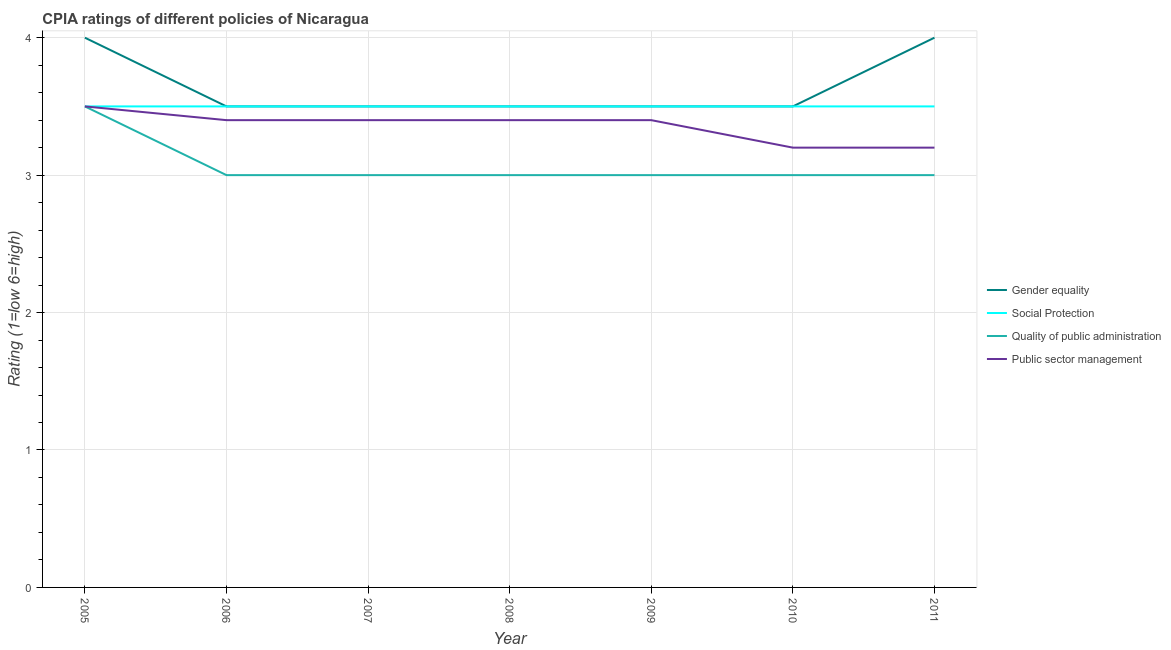Does the line corresponding to cpia rating of quality of public administration intersect with the line corresponding to cpia rating of gender equality?
Ensure brevity in your answer.  No. Is the number of lines equal to the number of legend labels?
Ensure brevity in your answer.  Yes. Across all years, what is the maximum cpia rating of gender equality?
Offer a very short reply. 4. In which year was the cpia rating of social protection minimum?
Keep it short and to the point. 2005. What is the total cpia rating of quality of public administration in the graph?
Your response must be concise. 21.5. What is the difference between the cpia rating of public sector management in 2005 and that in 2008?
Your answer should be very brief. 0.1. What is the average cpia rating of public sector management per year?
Make the answer very short. 3.36. In the year 2006, what is the difference between the cpia rating of public sector management and cpia rating of quality of public administration?
Your answer should be very brief. 0.4. In how many years, is the cpia rating of social protection greater than 1.2?
Keep it short and to the point. 7. Is the difference between the cpia rating of gender equality in 2006 and 2008 greater than the difference between the cpia rating of social protection in 2006 and 2008?
Your response must be concise. No. What is the difference between the highest and the lowest cpia rating of quality of public administration?
Make the answer very short. 0.5. Is it the case that in every year, the sum of the cpia rating of gender equality and cpia rating of social protection is greater than the cpia rating of quality of public administration?
Offer a very short reply. Yes. Does the cpia rating of gender equality monotonically increase over the years?
Provide a succinct answer. No. Is the cpia rating of social protection strictly less than the cpia rating of quality of public administration over the years?
Give a very brief answer. No. Are the values on the major ticks of Y-axis written in scientific E-notation?
Provide a succinct answer. No. Does the graph contain grids?
Make the answer very short. Yes. What is the title of the graph?
Offer a terse response. CPIA ratings of different policies of Nicaragua. Does "Italy" appear as one of the legend labels in the graph?
Provide a short and direct response. No. What is the Rating (1=low 6=high) of Gender equality in 2005?
Your answer should be compact. 4. What is the Rating (1=low 6=high) of Social Protection in 2005?
Keep it short and to the point. 3.5. What is the Rating (1=low 6=high) in Quality of public administration in 2005?
Ensure brevity in your answer.  3.5. What is the Rating (1=low 6=high) in Public sector management in 2006?
Make the answer very short. 3.4. What is the Rating (1=low 6=high) of Gender equality in 2007?
Provide a succinct answer. 3.5. What is the Rating (1=low 6=high) of Public sector management in 2007?
Your answer should be compact. 3.4. What is the Rating (1=low 6=high) of Gender equality in 2008?
Make the answer very short. 3.5. What is the Rating (1=low 6=high) of Social Protection in 2008?
Offer a terse response. 3.5. What is the Rating (1=low 6=high) of Social Protection in 2009?
Make the answer very short. 3.5. What is the Rating (1=low 6=high) of Public sector management in 2009?
Provide a short and direct response. 3.4. What is the Rating (1=low 6=high) in Gender equality in 2010?
Your answer should be compact. 3.5. What is the Rating (1=low 6=high) of Quality of public administration in 2010?
Offer a very short reply. 3. What is the Rating (1=low 6=high) of Public sector management in 2010?
Your answer should be very brief. 3.2. What is the Rating (1=low 6=high) of Social Protection in 2011?
Provide a short and direct response. 3.5. What is the Rating (1=low 6=high) of Quality of public administration in 2011?
Provide a short and direct response. 3. Across all years, what is the minimum Rating (1=low 6=high) in Gender equality?
Your answer should be very brief. 3.5. Across all years, what is the minimum Rating (1=low 6=high) of Social Protection?
Offer a terse response. 3.5. What is the total Rating (1=low 6=high) in Gender equality in the graph?
Give a very brief answer. 25.5. What is the total Rating (1=low 6=high) of Quality of public administration in the graph?
Offer a very short reply. 21.5. What is the total Rating (1=low 6=high) of Public sector management in the graph?
Your answer should be compact. 23.5. What is the difference between the Rating (1=low 6=high) in Quality of public administration in 2005 and that in 2006?
Your answer should be compact. 0.5. What is the difference between the Rating (1=low 6=high) in Public sector management in 2005 and that in 2006?
Your answer should be compact. 0.1. What is the difference between the Rating (1=low 6=high) of Quality of public administration in 2005 and that in 2007?
Provide a succinct answer. 0.5. What is the difference between the Rating (1=low 6=high) in Gender equality in 2005 and that in 2008?
Ensure brevity in your answer.  0.5. What is the difference between the Rating (1=low 6=high) of Gender equality in 2005 and that in 2009?
Provide a succinct answer. 0.5. What is the difference between the Rating (1=low 6=high) of Gender equality in 2005 and that in 2010?
Your response must be concise. 0.5. What is the difference between the Rating (1=low 6=high) of Social Protection in 2005 and that in 2010?
Your response must be concise. 0. What is the difference between the Rating (1=low 6=high) of Public sector management in 2005 and that in 2010?
Ensure brevity in your answer.  0.3. What is the difference between the Rating (1=low 6=high) in Gender equality in 2005 and that in 2011?
Give a very brief answer. 0. What is the difference between the Rating (1=low 6=high) of Social Protection in 2005 and that in 2011?
Provide a succinct answer. 0. What is the difference between the Rating (1=low 6=high) of Gender equality in 2006 and that in 2007?
Ensure brevity in your answer.  0. What is the difference between the Rating (1=low 6=high) in Social Protection in 2006 and that in 2007?
Offer a very short reply. 0. What is the difference between the Rating (1=low 6=high) of Quality of public administration in 2006 and that in 2007?
Ensure brevity in your answer.  0. What is the difference between the Rating (1=low 6=high) in Gender equality in 2006 and that in 2008?
Provide a short and direct response. 0. What is the difference between the Rating (1=low 6=high) of Quality of public administration in 2006 and that in 2008?
Provide a short and direct response. 0. What is the difference between the Rating (1=low 6=high) in Gender equality in 2006 and that in 2009?
Give a very brief answer. 0. What is the difference between the Rating (1=low 6=high) in Quality of public administration in 2006 and that in 2009?
Offer a very short reply. 0. What is the difference between the Rating (1=low 6=high) in Public sector management in 2006 and that in 2009?
Make the answer very short. 0. What is the difference between the Rating (1=low 6=high) in Gender equality in 2006 and that in 2010?
Make the answer very short. 0. What is the difference between the Rating (1=low 6=high) in Social Protection in 2006 and that in 2010?
Provide a short and direct response. 0. What is the difference between the Rating (1=low 6=high) of Public sector management in 2006 and that in 2010?
Offer a terse response. 0.2. What is the difference between the Rating (1=low 6=high) of Social Protection in 2006 and that in 2011?
Ensure brevity in your answer.  0. What is the difference between the Rating (1=low 6=high) in Quality of public administration in 2006 and that in 2011?
Keep it short and to the point. 0. What is the difference between the Rating (1=low 6=high) in Gender equality in 2007 and that in 2008?
Offer a very short reply. 0. What is the difference between the Rating (1=low 6=high) in Social Protection in 2007 and that in 2008?
Make the answer very short. 0. What is the difference between the Rating (1=low 6=high) of Public sector management in 2007 and that in 2008?
Your response must be concise. 0. What is the difference between the Rating (1=low 6=high) in Gender equality in 2007 and that in 2009?
Make the answer very short. 0. What is the difference between the Rating (1=low 6=high) in Quality of public administration in 2007 and that in 2009?
Give a very brief answer. 0. What is the difference between the Rating (1=low 6=high) in Social Protection in 2007 and that in 2010?
Provide a short and direct response. 0. What is the difference between the Rating (1=low 6=high) of Social Protection in 2007 and that in 2011?
Provide a short and direct response. 0. What is the difference between the Rating (1=low 6=high) of Quality of public administration in 2007 and that in 2011?
Your response must be concise. 0. What is the difference between the Rating (1=low 6=high) of Public sector management in 2007 and that in 2011?
Your answer should be compact. 0.2. What is the difference between the Rating (1=low 6=high) in Gender equality in 2008 and that in 2009?
Give a very brief answer. 0. What is the difference between the Rating (1=low 6=high) of Social Protection in 2008 and that in 2009?
Make the answer very short. 0. What is the difference between the Rating (1=low 6=high) in Gender equality in 2008 and that in 2010?
Give a very brief answer. 0. What is the difference between the Rating (1=low 6=high) in Social Protection in 2008 and that in 2010?
Make the answer very short. 0. What is the difference between the Rating (1=low 6=high) in Quality of public administration in 2008 and that in 2010?
Your response must be concise. 0. What is the difference between the Rating (1=low 6=high) in Social Protection in 2008 and that in 2011?
Your response must be concise. 0. What is the difference between the Rating (1=low 6=high) in Social Protection in 2009 and that in 2010?
Ensure brevity in your answer.  0. What is the difference between the Rating (1=low 6=high) of Quality of public administration in 2009 and that in 2010?
Offer a very short reply. 0. What is the difference between the Rating (1=low 6=high) of Public sector management in 2009 and that in 2010?
Your answer should be compact. 0.2. What is the difference between the Rating (1=low 6=high) of Quality of public administration in 2009 and that in 2011?
Provide a succinct answer. 0. What is the difference between the Rating (1=low 6=high) in Public sector management in 2009 and that in 2011?
Ensure brevity in your answer.  0.2. What is the difference between the Rating (1=low 6=high) in Gender equality in 2010 and that in 2011?
Ensure brevity in your answer.  -0.5. What is the difference between the Rating (1=low 6=high) in Gender equality in 2005 and the Rating (1=low 6=high) in Quality of public administration in 2006?
Provide a succinct answer. 1. What is the difference between the Rating (1=low 6=high) of Gender equality in 2005 and the Rating (1=low 6=high) of Public sector management in 2006?
Your answer should be compact. 0.6. What is the difference between the Rating (1=low 6=high) in Gender equality in 2005 and the Rating (1=low 6=high) in Social Protection in 2007?
Ensure brevity in your answer.  0.5. What is the difference between the Rating (1=low 6=high) in Social Protection in 2005 and the Rating (1=low 6=high) in Quality of public administration in 2007?
Your answer should be compact. 0.5. What is the difference between the Rating (1=low 6=high) of Social Protection in 2005 and the Rating (1=low 6=high) of Public sector management in 2007?
Make the answer very short. 0.1. What is the difference between the Rating (1=low 6=high) in Gender equality in 2005 and the Rating (1=low 6=high) in Social Protection in 2008?
Give a very brief answer. 0.5. What is the difference between the Rating (1=low 6=high) of Gender equality in 2005 and the Rating (1=low 6=high) of Quality of public administration in 2008?
Ensure brevity in your answer.  1. What is the difference between the Rating (1=low 6=high) in Gender equality in 2005 and the Rating (1=low 6=high) in Public sector management in 2008?
Your answer should be compact. 0.6. What is the difference between the Rating (1=low 6=high) in Quality of public administration in 2005 and the Rating (1=low 6=high) in Public sector management in 2008?
Your answer should be very brief. 0.1. What is the difference between the Rating (1=low 6=high) in Gender equality in 2005 and the Rating (1=low 6=high) in Quality of public administration in 2009?
Give a very brief answer. 1. What is the difference between the Rating (1=low 6=high) in Social Protection in 2005 and the Rating (1=low 6=high) in Quality of public administration in 2009?
Provide a short and direct response. 0.5. What is the difference between the Rating (1=low 6=high) of Social Protection in 2005 and the Rating (1=low 6=high) of Quality of public administration in 2010?
Provide a succinct answer. 0.5. What is the difference between the Rating (1=low 6=high) in Gender equality in 2005 and the Rating (1=low 6=high) in Social Protection in 2011?
Your answer should be compact. 0.5. What is the difference between the Rating (1=low 6=high) in Gender equality in 2005 and the Rating (1=low 6=high) in Quality of public administration in 2011?
Make the answer very short. 1. What is the difference between the Rating (1=low 6=high) of Gender equality in 2006 and the Rating (1=low 6=high) of Quality of public administration in 2007?
Your response must be concise. 0.5. What is the difference between the Rating (1=low 6=high) of Social Protection in 2006 and the Rating (1=low 6=high) of Quality of public administration in 2007?
Your answer should be very brief. 0.5. What is the difference between the Rating (1=low 6=high) in Social Protection in 2006 and the Rating (1=low 6=high) in Public sector management in 2007?
Give a very brief answer. 0.1. What is the difference between the Rating (1=low 6=high) of Quality of public administration in 2006 and the Rating (1=low 6=high) of Public sector management in 2007?
Provide a succinct answer. -0.4. What is the difference between the Rating (1=low 6=high) of Gender equality in 2006 and the Rating (1=low 6=high) of Social Protection in 2008?
Offer a terse response. 0. What is the difference between the Rating (1=low 6=high) of Gender equality in 2006 and the Rating (1=low 6=high) of Public sector management in 2008?
Your answer should be compact. 0.1. What is the difference between the Rating (1=low 6=high) in Social Protection in 2006 and the Rating (1=low 6=high) in Public sector management in 2008?
Provide a succinct answer. 0.1. What is the difference between the Rating (1=low 6=high) in Quality of public administration in 2006 and the Rating (1=low 6=high) in Public sector management in 2008?
Your answer should be very brief. -0.4. What is the difference between the Rating (1=low 6=high) of Gender equality in 2006 and the Rating (1=low 6=high) of Public sector management in 2009?
Your response must be concise. 0.1. What is the difference between the Rating (1=low 6=high) of Social Protection in 2006 and the Rating (1=low 6=high) of Quality of public administration in 2009?
Offer a very short reply. 0.5. What is the difference between the Rating (1=low 6=high) in Social Protection in 2006 and the Rating (1=low 6=high) in Public sector management in 2009?
Offer a terse response. 0.1. What is the difference between the Rating (1=low 6=high) of Gender equality in 2006 and the Rating (1=low 6=high) of Social Protection in 2010?
Give a very brief answer. 0. What is the difference between the Rating (1=low 6=high) of Gender equality in 2006 and the Rating (1=low 6=high) of Public sector management in 2010?
Offer a terse response. 0.3. What is the difference between the Rating (1=low 6=high) in Social Protection in 2006 and the Rating (1=low 6=high) in Quality of public administration in 2010?
Offer a terse response. 0.5. What is the difference between the Rating (1=low 6=high) in Social Protection in 2006 and the Rating (1=low 6=high) in Public sector management in 2010?
Ensure brevity in your answer.  0.3. What is the difference between the Rating (1=low 6=high) in Gender equality in 2006 and the Rating (1=low 6=high) in Quality of public administration in 2011?
Ensure brevity in your answer.  0.5. What is the difference between the Rating (1=low 6=high) in Social Protection in 2006 and the Rating (1=low 6=high) in Public sector management in 2011?
Keep it short and to the point. 0.3. What is the difference between the Rating (1=low 6=high) of Quality of public administration in 2006 and the Rating (1=low 6=high) of Public sector management in 2011?
Your answer should be compact. -0.2. What is the difference between the Rating (1=low 6=high) in Gender equality in 2007 and the Rating (1=low 6=high) in Public sector management in 2008?
Provide a succinct answer. 0.1. What is the difference between the Rating (1=low 6=high) of Quality of public administration in 2007 and the Rating (1=low 6=high) of Public sector management in 2008?
Provide a succinct answer. -0.4. What is the difference between the Rating (1=low 6=high) in Gender equality in 2007 and the Rating (1=low 6=high) in Social Protection in 2009?
Provide a succinct answer. 0. What is the difference between the Rating (1=low 6=high) in Gender equality in 2007 and the Rating (1=low 6=high) in Quality of public administration in 2009?
Ensure brevity in your answer.  0.5. What is the difference between the Rating (1=low 6=high) in Social Protection in 2007 and the Rating (1=low 6=high) in Public sector management in 2009?
Your answer should be compact. 0.1. What is the difference between the Rating (1=low 6=high) in Quality of public administration in 2007 and the Rating (1=low 6=high) in Public sector management in 2009?
Keep it short and to the point. -0.4. What is the difference between the Rating (1=low 6=high) of Gender equality in 2007 and the Rating (1=low 6=high) of Quality of public administration in 2010?
Offer a terse response. 0.5. What is the difference between the Rating (1=low 6=high) of Gender equality in 2007 and the Rating (1=low 6=high) of Public sector management in 2010?
Provide a short and direct response. 0.3. What is the difference between the Rating (1=low 6=high) of Social Protection in 2007 and the Rating (1=low 6=high) of Quality of public administration in 2010?
Offer a terse response. 0.5. What is the difference between the Rating (1=low 6=high) in Gender equality in 2007 and the Rating (1=low 6=high) in Social Protection in 2011?
Provide a short and direct response. 0. What is the difference between the Rating (1=low 6=high) of Gender equality in 2007 and the Rating (1=low 6=high) of Quality of public administration in 2011?
Offer a terse response. 0.5. What is the difference between the Rating (1=low 6=high) in Gender equality in 2007 and the Rating (1=low 6=high) in Public sector management in 2011?
Ensure brevity in your answer.  0.3. What is the difference between the Rating (1=low 6=high) in Quality of public administration in 2007 and the Rating (1=low 6=high) in Public sector management in 2011?
Offer a very short reply. -0.2. What is the difference between the Rating (1=low 6=high) in Gender equality in 2008 and the Rating (1=low 6=high) in Quality of public administration in 2009?
Provide a succinct answer. 0.5. What is the difference between the Rating (1=low 6=high) in Gender equality in 2008 and the Rating (1=low 6=high) in Public sector management in 2009?
Provide a short and direct response. 0.1. What is the difference between the Rating (1=low 6=high) in Social Protection in 2008 and the Rating (1=low 6=high) in Quality of public administration in 2010?
Your answer should be compact. 0.5. What is the difference between the Rating (1=low 6=high) of Social Protection in 2008 and the Rating (1=low 6=high) of Public sector management in 2010?
Keep it short and to the point. 0.3. What is the difference between the Rating (1=low 6=high) of Quality of public administration in 2008 and the Rating (1=low 6=high) of Public sector management in 2010?
Provide a short and direct response. -0.2. What is the difference between the Rating (1=low 6=high) in Gender equality in 2008 and the Rating (1=low 6=high) in Public sector management in 2011?
Offer a terse response. 0.3. What is the difference between the Rating (1=low 6=high) in Social Protection in 2008 and the Rating (1=low 6=high) in Quality of public administration in 2011?
Offer a terse response. 0.5. What is the difference between the Rating (1=low 6=high) in Gender equality in 2009 and the Rating (1=low 6=high) in Quality of public administration in 2010?
Your answer should be compact. 0.5. What is the difference between the Rating (1=low 6=high) in Gender equality in 2009 and the Rating (1=low 6=high) in Public sector management in 2010?
Make the answer very short. 0.3. What is the difference between the Rating (1=low 6=high) in Social Protection in 2009 and the Rating (1=low 6=high) in Quality of public administration in 2010?
Give a very brief answer. 0.5. What is the difference between the Rating (1=low 6=high) in Social Protection in 2009 and the Rating (1=low 6=high) in Public sector management in 2010?
Your response must be concise. 0.3. What is the difference between the Rating (1=low 6=high) in Social Protection in 2009 and the Rating (1=low 6=high) in Quality of public administration in 2011?
Make the answer very short. 0.5. What is the difference between the Rating (1=low 6=high) of Social Protection in 2009 and the Rating (1=low 6=high) of Public sector management in 2011?
Keep it short and to the point. 0.3. What is the difference between the Rating (1=low 6=high) of Quality of public administration in 2009 and the Rating (1=low 6=high) of Public sector management in 2011?
Offer a very short reply. -0.2. What is the difference between the Rating (1=low 6=high) in Gender equality in 2010 and the Rating (1=low 6=high) in Social Protection in 2011?
Offer a very short reply. 0. What is the difference between the Rating (1=low 6=high) in Gender equality in 2010 and the Rating (1=low 6=high) in Quality of public administration in 2011?
Your answer should be compact. 0.5. What is the difference between the Rating (1=low 6=high) of Gender equality in 2010 and the Rating (1=low 6=high) of Public sector management in 2011?
Ensure brevity in your answer.  0.3. What is the difference between the Rating (1=low 6=high) in Quality of public administration in 2010 and the Rating (1=low 6=high) in Public sector management in 2011?
Offer a terse response. -0.2. What is the average Rating (1=low 6=high) in Gender equality per year?
Give a very brief answer. 3.64. What is the average Rating (1=low 6=high) of Quality of public administration per year?
Your answer should be compact. 3.07. What is the average Rating (1=low 6=high) of Public sector management per year?
Your answer should be very brief. 3.36. In the year 2005, what is the difference between the Rating (1=low 6=high) of Gender equality and Rating (1=low 6=high) of Quality of public administration?
Offer a terse response. 0.5. In the year 2005, what is the difference between the Rating (1=low 6=high) of Gender equality and Rating (1=low 6=high) of Public sector management?
Offer a terse response. 0.5. In the year 2005, what is the difference between the Rating (1=low 6=high) of Social Protection and Rating (1=low 6=high) of Quality of public administration?
Your answer should be very brief. 0. In the year 2006, what is the difference between the Rating (1=low 6=high) in Gender equality and Rating (1=low 6=high) in Social Protection?
Give a very brief answer. 0. In the year 2006, what is the difference between the Rating (1=low 6=high) of Gender equality and Rating (1=low 6=high) of Quality of public administration?
Offer a very short reply. 0.5. In the year 2006, what is the difference between the Rating (1=low 6=high) in Social Protection and Rating (1=low 6=high) in Quality of public administration?
Give a very brief answer. 0.5. In the year 2007, what is the difference between the Rating (1=low 6=high) of Gender equality and Rating (1=low 6=high) of Social Protection?
Offer a terse response. 0. In the year 2007, what is the difference between the Rating (1=low 6=high) of Social Protection and Rating (1=low 6=high) of Quality of public administration?
Your response must be concise. 0.5. In the year 2007, what is the difference between the Rating (1=low 6=high) of Social Protection and Rating (1=low 6=high) of Public sector management?
Offer a very short reply. 0.1. In the year 2008, what is the difference between the Rating (1=low 6=high) of Social Protection and Rating (1=low 6=high) of Quality of public administration?
Give a very brief answer. 0.5. In the year 2008, what is the difference between the Rating (1=low 6=high) of Social Protection and Rating (1=low 6=high) of Public sector management?
Keep it short and to the point. 0.1. In the year 2009, what is the difference between the Rating (1=low 6=high) in Gender equality and Rating (1=low 6=high) in Public sector management?
Your answer should be compact. 0.1. In the year 2009, what is the difference between the Rating (1=low 6=high) of Social Protection and Rating (1=low 6=high) of Public sector management?
Your response must be concise. 0.1. In the year 2010, what is the difference between the Rating (1=low 6=high) in Gender equality and Rating (1=low 6=high) in Social Protection?
Ensure brevity in your answer.  0. In the year 2010, what is the difference between the Rating (1=low 6=high) of Gender equality and Rating (1=low 6=high) of Quality of public administration?
Provide a short and direct response. 0.5. In the year 2010, what is the difference between the Rating (1=low 6=high) in Gender equality and Rating (1=low 6=high) in Public sector management?
Ensure brevity in your answer.  0.3. In the year 2010, what is the difference between the Rating (1=low 6=high) in Social Protection and Rating (1=low 6=high) in Quality of public administration?
Ensure brevity in your answer.  0.5. In the year 2010, what is the difference between the Rating (1=low 6=high) in Social Protection and Rating (1=low 6=high) in Public sector management?
Offer a terse response. 0.3. In the year 2011, what is the difference between the Rating (1=low 6=high) of Gender equality and Rating (1=low 6=high) of Social Protection?
Give a very brief answer. 0.5. In the year 2011, what is the difference between the Rating (1=low 6=high) in Social Protection and Rating (1=low 6=high) in Quality of public administration?
Make the answer very short. 0.5. What is the ratio of the Rating (1=low 6=high) in Social Protection in 2005 to that in 2006?
Provide a short and direct response. 1. What is the ratio of the Rating (1=low 6=high) in Quality of public administration in 2005 to that in 2006?
Make the answer very short. 1.17. What is the ratio of the Rating (1=low 6=high) of Public sector management in 2005 to that in 2006?
Make the answer very short. 1.03. What is the ratio of the Rating (1=low 6=high) in Gender equality in 2005 to that in 2007?
Offer a very short reply. 1.14. What is the ratio of the Rating (1=low 6=high) in Social Protection in 2005 to that in 2007?
Keep it short and to the point. 1. What is the ratio of the Rating (1=low 6=high) of Public sector management in 2005 to that in 2007?
Provide a short and direct response. 1.03. What is the ratio of the Rating (1=low 6=high) of Public sector management in 2005 to that in 2008?
Your response must be concise. 1.03. What is the ratio of the Rating (1=low 6=high) of Gender equality in 2005 to that in 2009?
Your response must be concise. 1.14. What is the ratio of the Rating (1=low 6=high) in Social Protection in 2005 to that in 2009?
Give a very brief answer. 1. What is the ratio of the Rating (1=low 6=high) in Quality of public administration in 2005 to that in 2009?
Your answer should be compact. 1.17. What is the ratio of the Rating (1=low 6=high) in Public sector management in 2005 to that in 2009?
Keep it short and to the point. 1.03. What is the ratio of the Rating (1=low 6=high) in Gender equality in 2005 to that in 2010?
Provide a succinct answer. 1.14. What is the ratio of the Rating (1=low 6=high) of Public sector management in 2005 to that in 2010?
Make the answer very short. 1.09. What is the ratio of the Rating (1=low 6=high) of Public sector management in 2005 to that in 2011?
Your answer should be very brief. 1.09. What is the ratio of the Rating (1=low 6=high) of Gender equality in 2006 to that in 2007?
Give a very brief answer. 1. What is the ratio of the Rating (1=low 6=high) of Social Protection in 2006 to that in 2007?
Offer a terse response. 1. What is the ratio of the Rating (1=low 6=high) in Public sector management in 2006 to that in 2007?
Your answer should be very brief. 1. What is the ratio of the Rating (1=low 6=high) in Gender equality in 2006 to that in 2009?
Ensure brevity in your answer.  1. What is the ratio of the Rating (1=low 6=high) of Gender equality in 2006 to that in 2010?
Your response must be concise. 1. What is the ratio of the Rating (1=low 6=high) of Social Protection in 2006 to that in 2010?
Ensure brevity in your answer.  1. What is the ratio of the Rating (1=low 6=high) in Public sector management in 2006 to that in 2010?
Your answer should be compact. 1.06. What is the ratio of the Rating (1=low 6=high) of Quality of public administration in 2006 to that in 2011?
Give a very brief answer. 1. What is the ratio of the Rating (1=low 6=high) in Public sector management in 2006 to that in 2011?
Your answer should be very brief. 1.06. What is the ratio of the Rating (1=low 6=high) of Gender equality in 2007 to that in 2008?
Give a very brief answer. 1. What is the ratio of the Rating (1=low 6=high) in Social Protection in 2007 to that in 2009?
Offer a terse response. 1. What is the ratio of the Rating (1=low 6=high) in Quality of public administration in 2007 to that in 2009?
Your answer should be very brief. 1. What is the ratio of the Rating (1=low 6=high) in Quality of public administration in 2007 to that in 2010?
Ensure brevity in your answer.  1. What is the ratio of the Rating (1=low 6=high) in Gender equality in 2007 to that in 2011?
Ensure brevity in your answer.  0.88. What is the ratio of the Rating (1=low 6=high) in Quality of public administration in 2007 to that in 2011?
Your answer should be compact. 1. What is the ratio of the Rating (1=low 6=high) of Public sector management in 2007 to that in 2011?
Offer a very short reply. 1.06. What is the ratio of the Rating (1=low 6=high) of Gender equality in 2008 to that in 2009?
Your response must be concise. 1. What is the ratio of the Rating (1=low 6=high) of Gender equality in 2008 to that in 2010?
Make the answer very short. 1. What is the ratio of the Rating (1=low 6=high) of Social Protection in 2008 to that in 2010?
Your answer should be very brief. 1. What is the ratio of the Rating (1=low 6=high) of Quality of public administration in 2008 to that in 2010?
Provide a succinct answer. 1. What is the ratio of the Rating (1=low 6=high) in Social Protection in 2008 to that in 2011?
Your response must be concise. 1. What is the ratio of the Rating (1=low 6=high) in Social Protection in 2009 to that in 2010?
Your answer should be compact. 1. What is the ratio of the Rating (1=low 6=high) in Public sector management in 2009 to that in 2010?
Offer a very short reply. 1.06. What is the ratio of the Rating (1=low 6=high) in Gender equality in 2010 to that in 2011?
Offer a very short reply. 0.88. What is the ratio of the Rating (1=low 6=high) of Social Protection in 2010 to that in 2011?
Give a very brief answer. 1. What is the ratio of the Rating (1=low 6=high) in Quality of public administration in 2010 to that in 2011?
Offer a very short reply. 1. What is the difference between the highest and the second highest Rating (1=low 6=high) in Quality of public administration?
Your response must be concise. 0.5. What is the difference between the highest and the second highest Rating (1=low 6=high) of Public sector management?
Your response must be concise. 0.1. What is the difference between the highest and the lowest Rating (1=low 6=high) in Social Protection?
Make the answer very short. 0. 